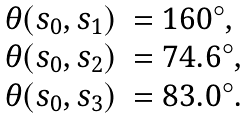<formula> <loc_0><loc_0><loc_500><loc_500>\begin{array} { r l } \theta ( s _ { 0 } , s _ { 1 } ) & = 1 6 0 ^ { \circ } , \\ \theta ( s _ { 0 } , s _ { 2 } ) & = 7 4 . 6 ^ { \circ } , \\ \theta ( s _ { 0 } , s _ { 3 } ) & = 8 3 . 0 ^ { \circ } . \end{array}</formula> 